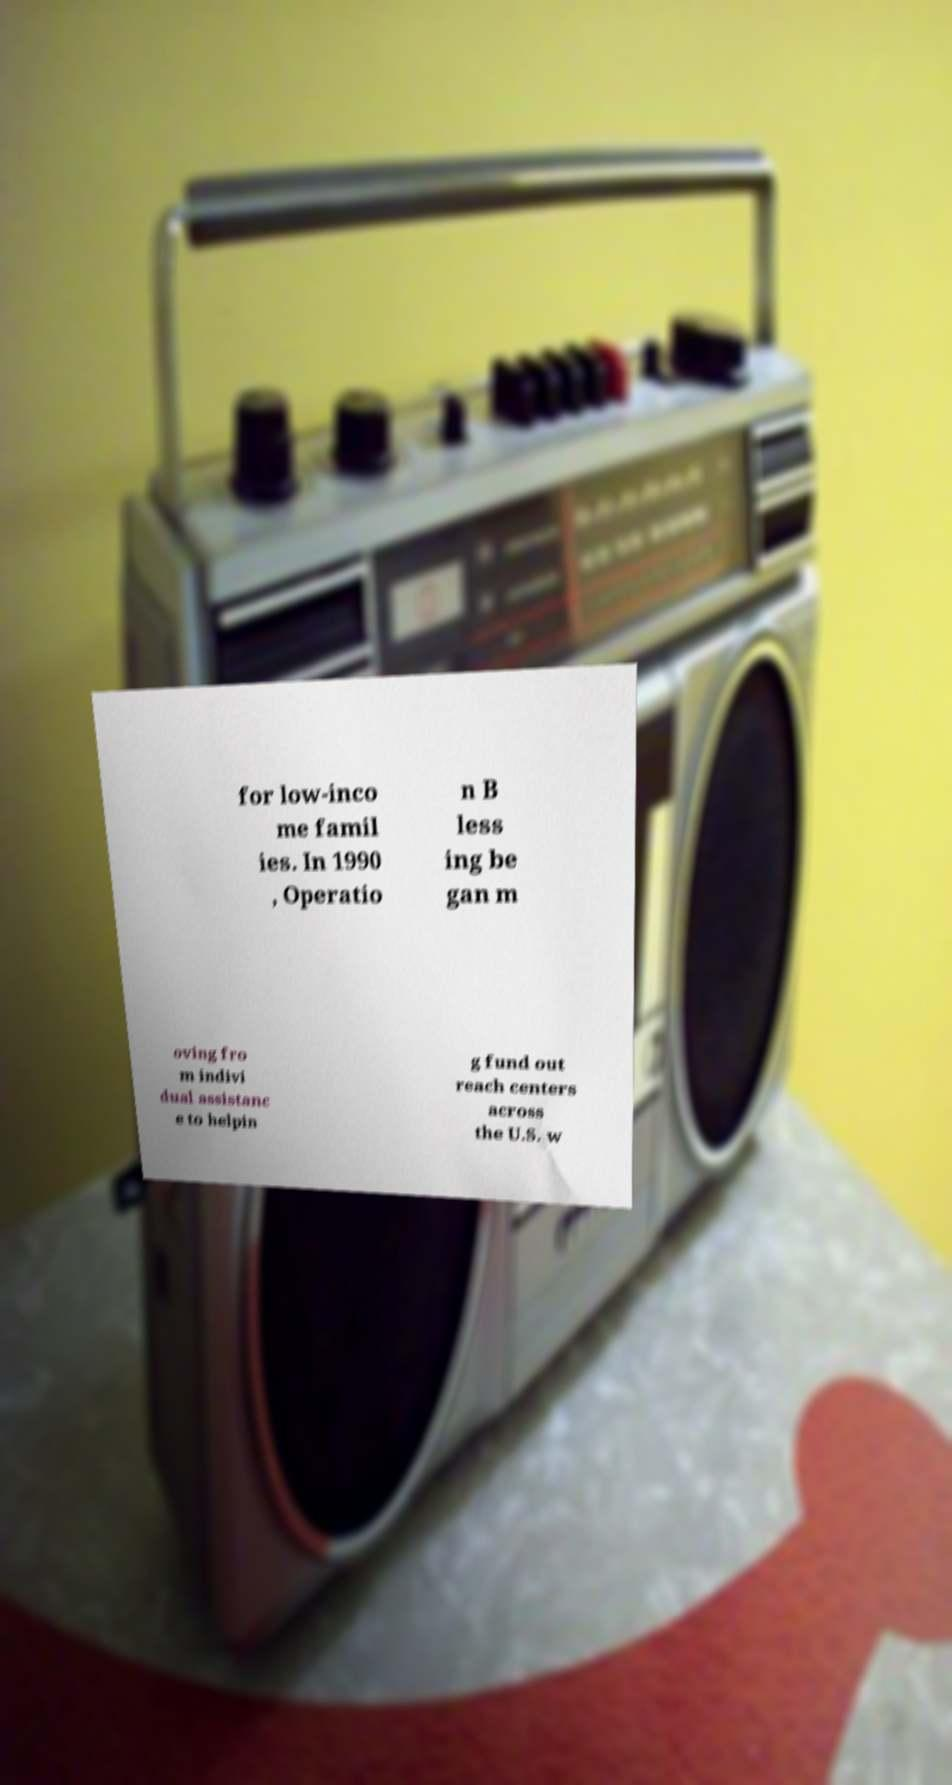Could you assist in decoding the text presented in this image and type it out clearly? for low-inco me famil ies. In 1990 , Operatio n B less ing be gan m oving fro m indivi dual assistanc e to helpin g fund out reach centers across the U.S. w 